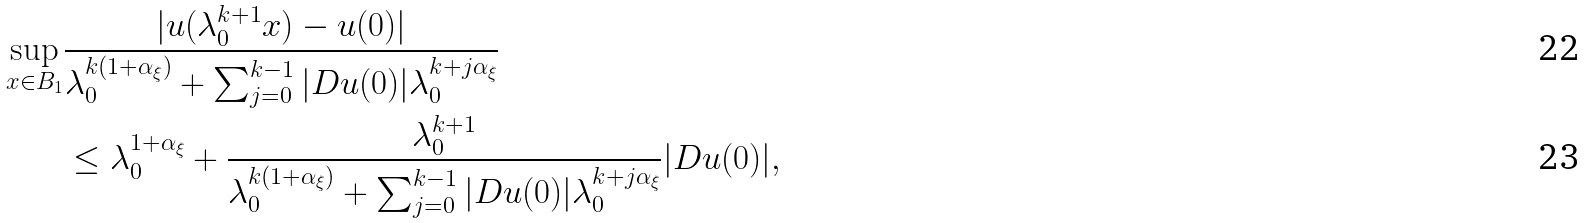Convert formula to latex. <formula><loc_0><loc_0><loc_500><loc_500>\sup _ { x \in B _ { 1 } } & \frac { | u ( \lambda ^ { k + 1 } _ { 0 } x ) - u ( 0 ) | } { \lambda ^ { k ( 1 + \alpha _ { \xi } ) } _ { 0 } + \sum ^ { k - 1 } _ { j = 0 } | D u ( 0 ) | \lambda ^ { k + j \alpha _ { \xi } } _ { 0 } } \\ & \leq \lambda ^ { 1 + \alpha _ { \xi } } _ { 0 } + \frac { \lambda ^ { k + 1 } _ { 0 } } { \lambda ^ { k ( 1 + \alpha _ { \xi } ) } _ { 0 } + \sum ^ { k - 1 } _ { j = 0 } | D u ( 0 ) | \lambda ^ { k + j \alpha _ { \xi } } _ { 0 } } | D u ( 0 ) | ,</formula> 